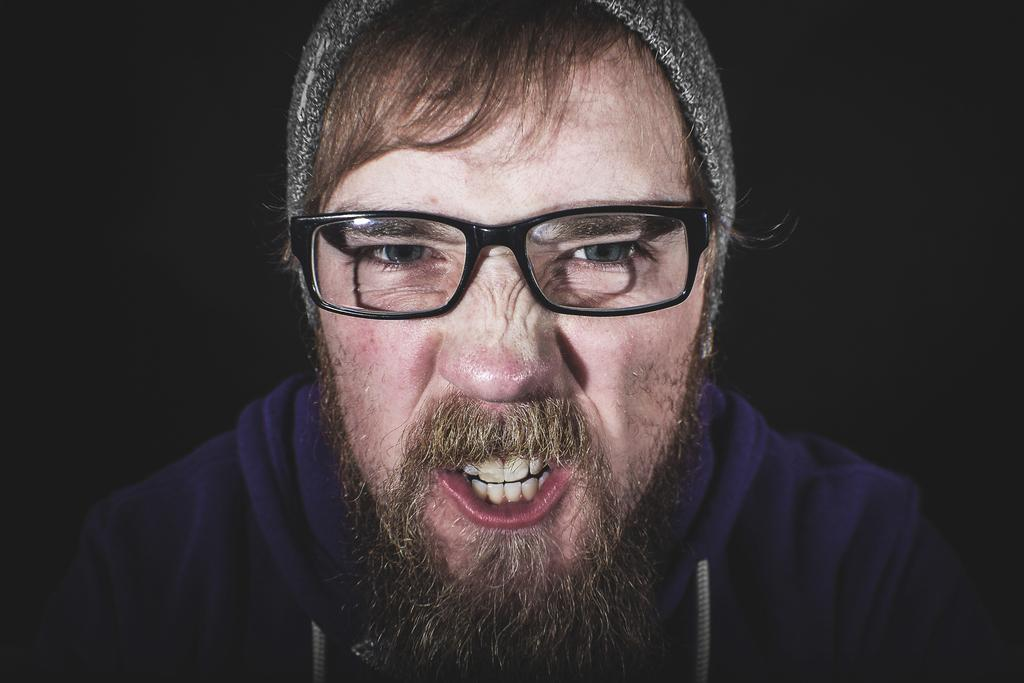Who is the main subject in the image? There is a man in the image. What can be observed about the man's appearance? The man is wearing spectacles and clothes. How would you describe the background of the image? The background of the image appears dark. What type of education does the squirrel in the image have? There is no squirrel present in the image, so it is not possible to determine its education. 